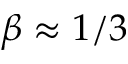<formula> <loc_0><loc_0><loc_500><loc_500>\beta \approx 1 / 3</formula> 